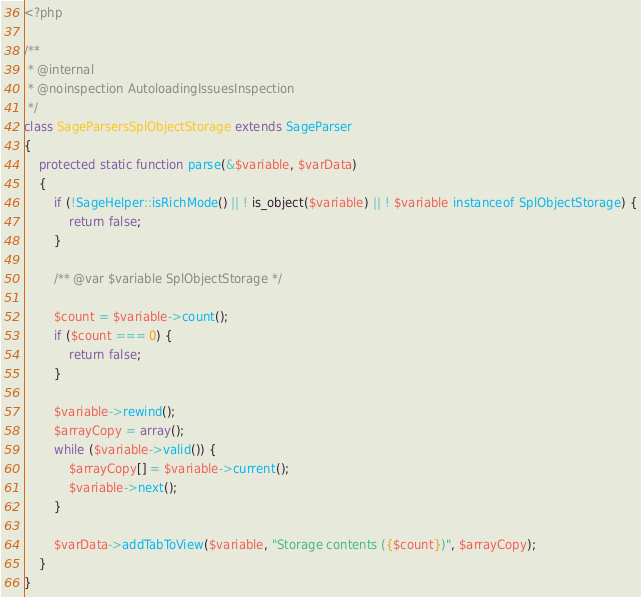Convert code to text. <code><loc_0><loc_0><loc_500><loc_500><_PHP_><?php

/**
 * @internal
 * @noinspection AutoloadingIssuesInspection
 */
class SageParsersSplObjectStorage extends SageParser
{
    protected static function parse(&$variable, $varData)
    {
        if (!SageHelper::isRichMode() || ! is_object($variable) || ! $variable instanceof SplObjectStorage) {
            return false;
        }

        /** @var $variable SplObjectStorage */

        $count = $variable->count();
        if ($count === 0) {
            return false;
        }

        $variable->rewind();
        $arrayCopy = array();
        while ($variable->valid()) {
            $arrayCopy[] = $variable->current();
            $variable->next();
        }

        $varData->addTabToView($variable, "Storage contents ({$count})", $arrayCopy);
    }
}</code> 